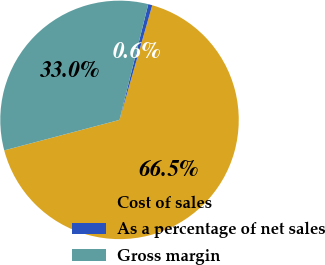Convert chart. <chart><loc_0><loc_0><loc_500><loc_500><pie_chart><fcel>Cost of sales<fcel>As a percentage of net sales<fcel>Gross margin<nl><fcel>66.45%<fcel>0.55%<fcel>32.99%<nl></chart> 